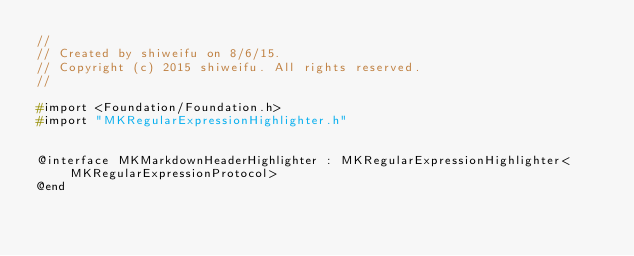<code> <loc_0><loc_0><loc_500><loc_500><_C_>//
// Created by shiweifu on 8/6/15.
// Copyright (c) 2015 shiweifu. All rights reserved.
//

#import <Foundation/Foundation.h>
#import "MKRegularExpressionHighlighter.h"


@interface MKMarkdownHeaderHighlighter : MKRegularExpressionHighlighter<MKRegularExpressionProtocol>
@end</code> 